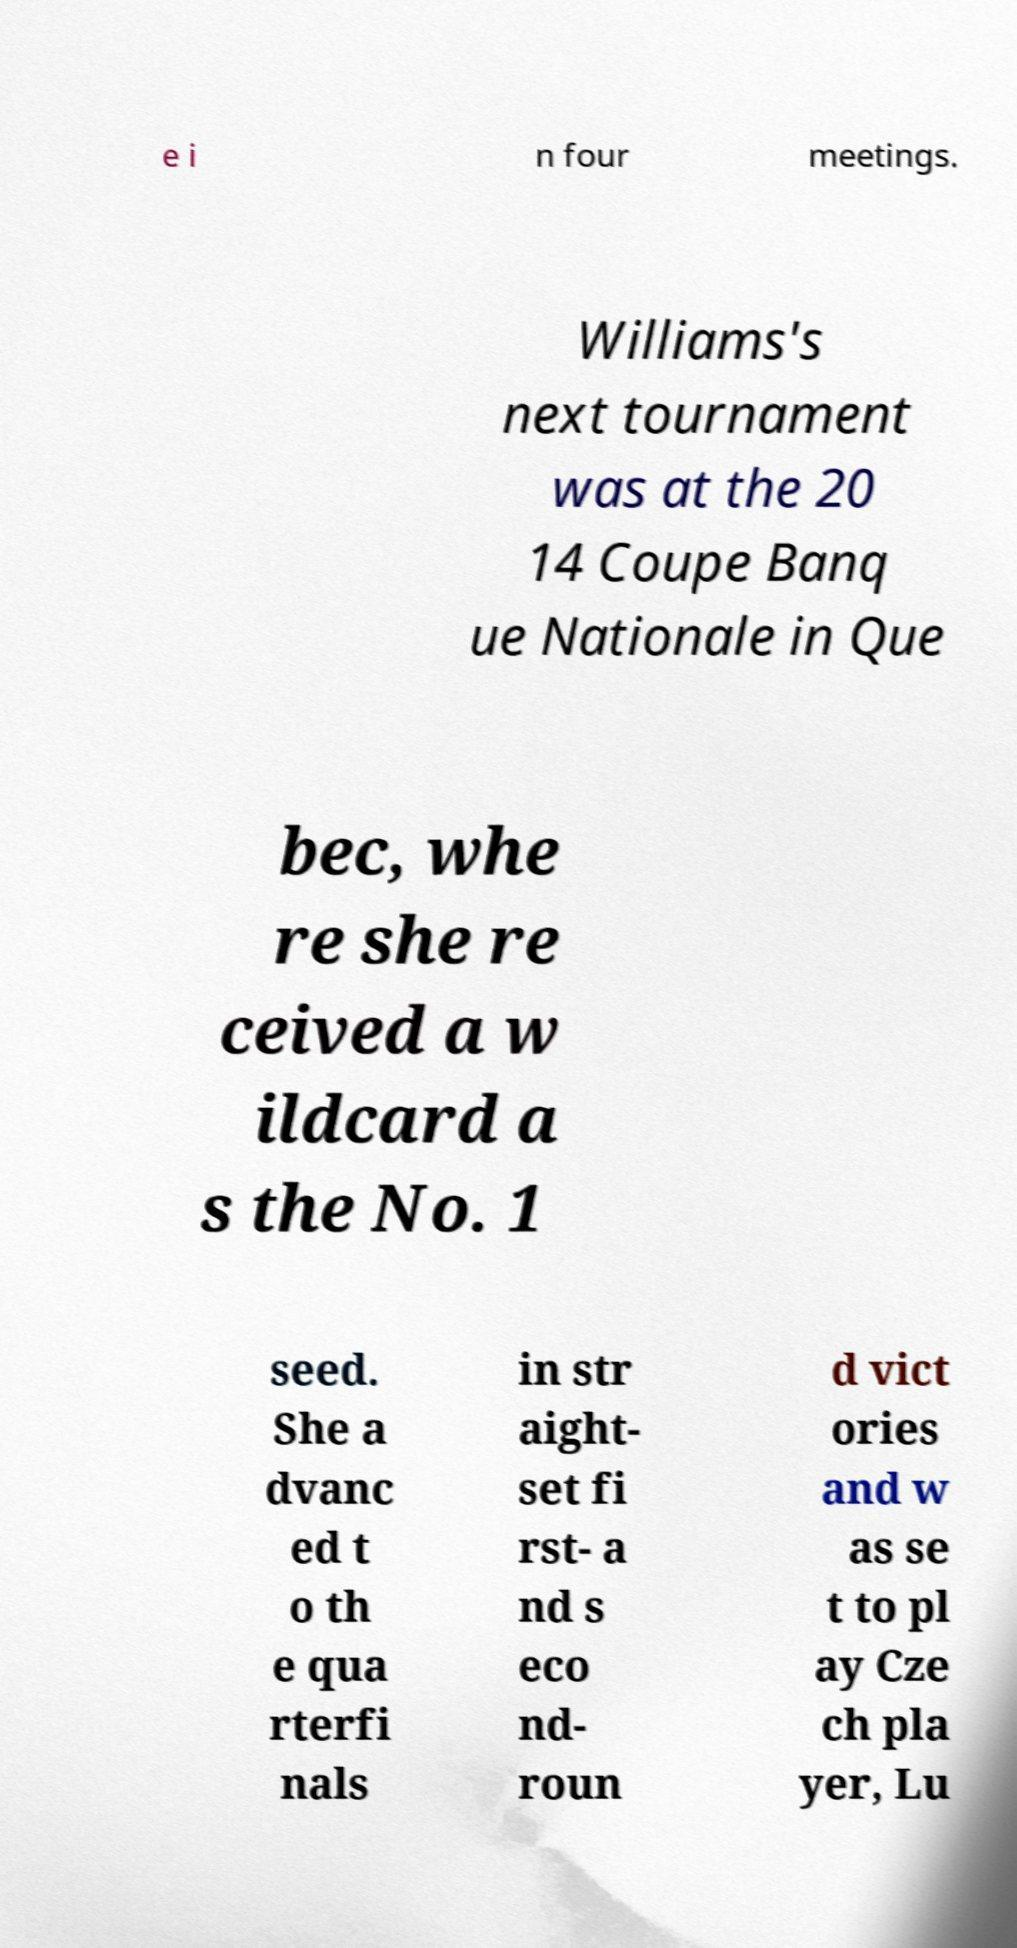Could you extract and type out the text from this image? e i n four meetings. Williams's next tournament was at the 20 14 Coupe Banq ue Nationale in Que bec, whe re she re ceived a w ildcard a s the No. 1 seed. She a dvanc ed t o th e qua rterfi nals in str aight- set fi rst- a nd s eco nd- roun d vict ories and w as se t to pl ay Cze ch pla yer, Lu 